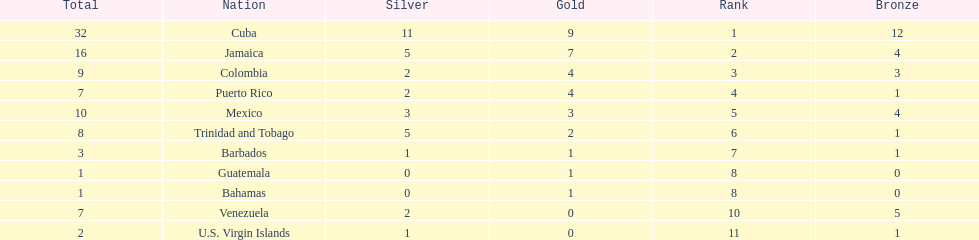Nations that had 10 or more medals each Cuba, Jamaica, Mexico. 